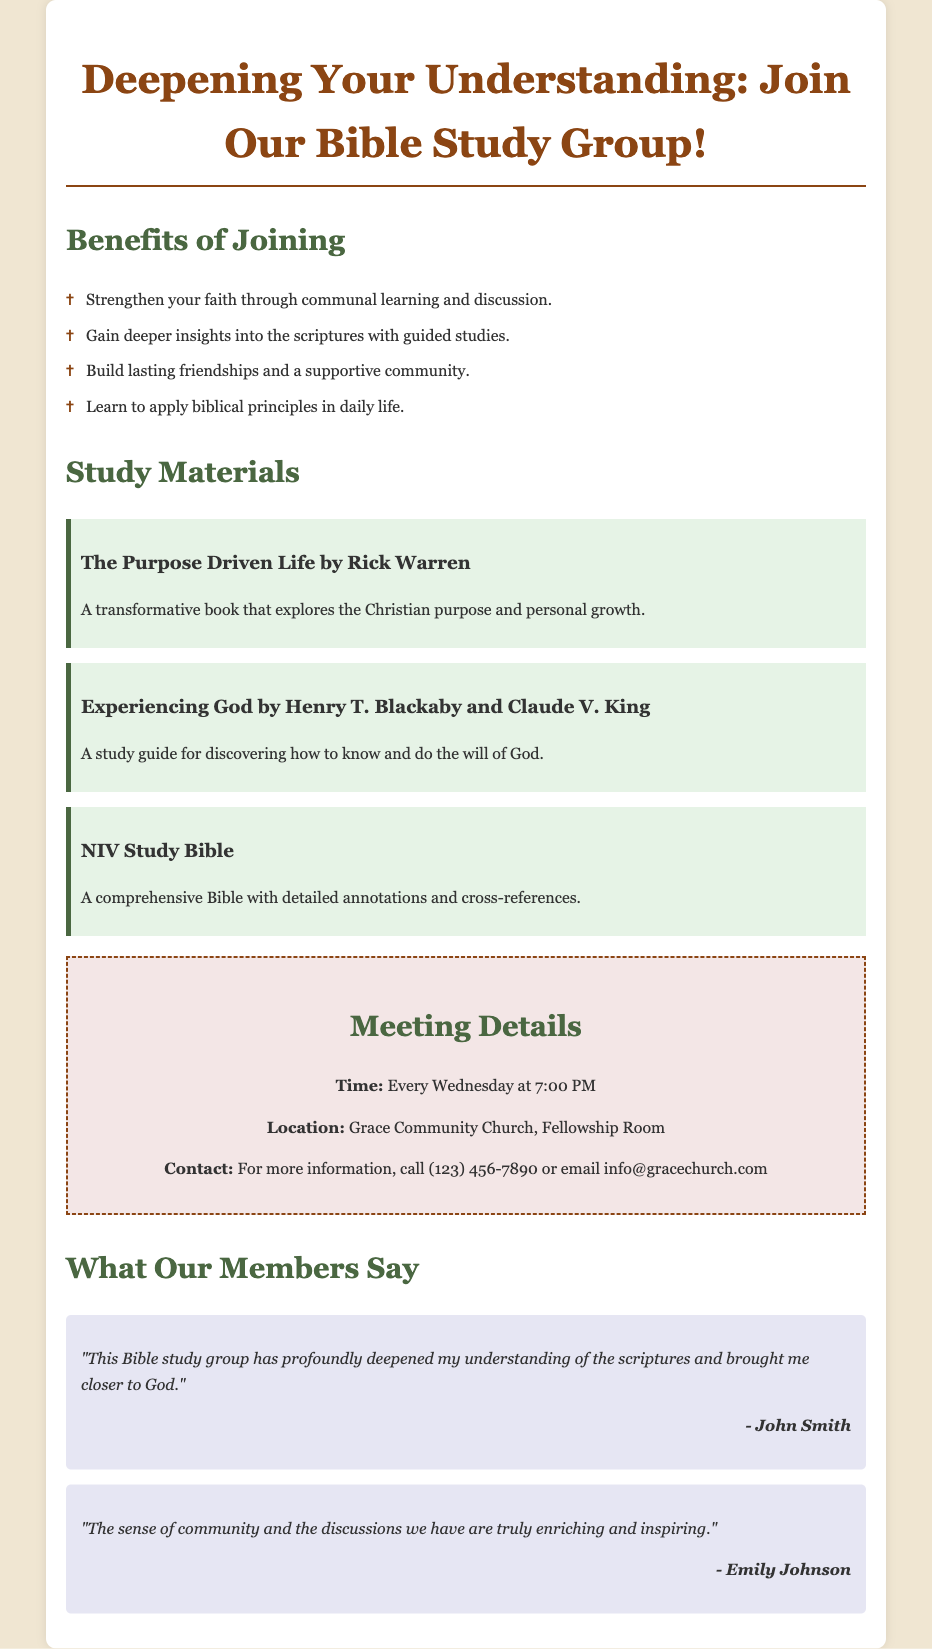What is the name of the first study material? The document lists "The Purpose Driven Life by Rick Warren" as the first study material under the study materials section.
Answer: The Purpose Driven Life by Rick Warren What day of the week does the group meet? The meeting time clearly states that the group meets "Every Wednesday at 7:00 PM."
Answer: Wednesday What location is mentioned for the Bible study group meetings? The location specified for the meetings is "Grace Community Church, Fellowship Room."
Answer: Grace Community Church, Fellowship Room How many study materials are listed in the document? There are three study materials listed in the document: "The Purpose Driven Life," "Experiencing God," and "NIV Study Bible."
Answer: Three What does John Smith say about the Bible study group? John Smith's quote highlights that the group has "profoundly deepened my understanding of the scriptures."
Answer: Deepened my understanding of the scriptures What type of group is being advertised? The document portrays a Bible study group focused on deepening understanding and faith through communal learning.
Answer: Bible study group How often does the Bible study group meet? The meeting frequency is specified as "Every Wednesday."
Answer: Every Wednesday 